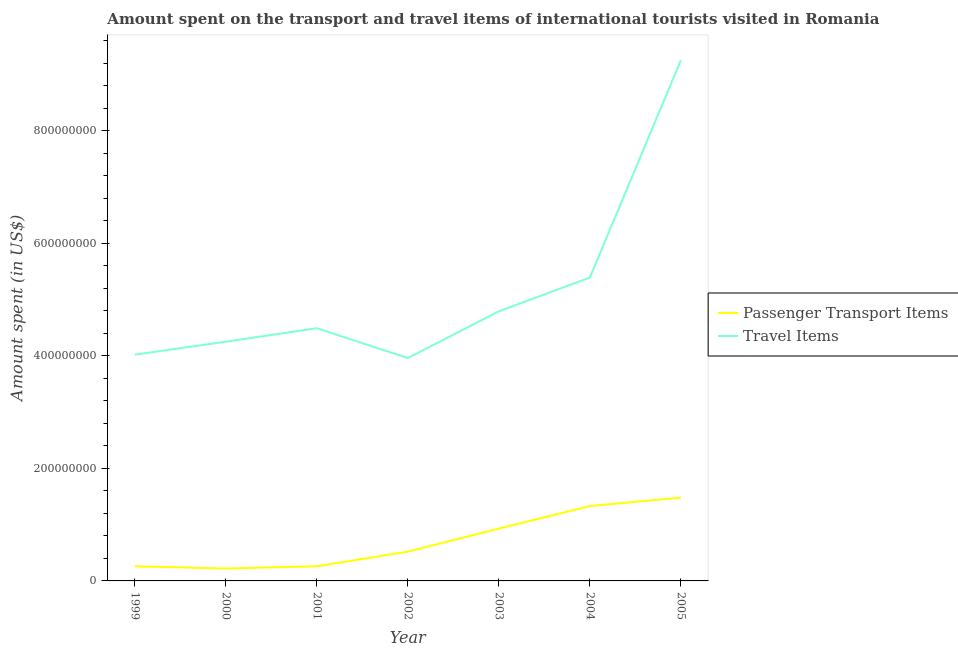What is the amount spent in travel items in 2004?
Give a very brief answer. 5.39e+08. Across all years, what is the maximum amount spent in travel items?
Keep it short and to the point. 9.25e+08. Across all years, what is the minimum amount spent on passenger transport items?
Your answer should be compact. 2.20e+07. In which year was the amount spent on passenger transport items maximum?
Give a very brief answer. 2005. In which year was the amount spent in travel items minimum?
Give a very brief answer. 2002. What is the total amount spent on passenger transport items in the graph?
Your answer should be compact. 5.00e+08. What is the difference between the amount spent on passenger transport items in 2001 and that in 2005?
Provide a short and direct response. -1.22e+08. What is the difference between the amount spent on passenger transport items in 2002 and the amount spent in travel items in 2000?
Ensure brevity in your answer.  -3.73e+08. What is the average amount spent on passenger transport items per year?
Give a very brief answer. 7.14e+07. In the year 2002, what is the difference between the amount spent in travel items and amount spent on passenger transport items?
Provide a short and direct response. 3.44e+08. In how many years, is the amount spent in travel items greater than 920000000 US$?
Ensure brevity in your answer.  1. What is the ratio of the amount spent in travel items in 1999 to that in 2002?
Provide a succinct answer. 1.02. Is the amount spent in travel items in 1999 less than that in 2004?
Make the answer very short. Yes. What is the difference between the highest and the second highest amount spent on passenger transport items?
Offer a very short reply. 1.50e+07. What is the difference between the highest and the lowest amount spent on passenger transport items?
Give a very brief answer. 1.26e+08. In how many years, is the amount spent in travel items greater than the average amount spent in travel items taken over all years?
Provide a succinct answer. 2. Is the sum of the amount spent on passenger transport items in 2003 and 2004 greater than the maximum amount spent in travel items across all years?
Make the answer very short. No. Is the amount spent on passenger transport items strictly greater than the amount spent in travel items over the years?
Your answer should be very brief. No. How many lines are there?
Offer a very short reply. 2. How many years are there in the graph?
Ensure brevity in your answer.  7. Does the graph contain grids?
Offer a very short reply. No. Where does the legend appear in the graph?
Ensure brevity in your answer.  Center right. How are the legend labels stacked?
Offer a terse response. Vertical. What is the title of the graph?
Provide a succinct answer. Amount spent on the transport and travel items of international tourists visited in Romania. What is the label or title of the Y-axis?
Your answer should be compact. Amount spent (in US$). What is the Amount spent (in US$) in Passenger Transport Items in 1999?
Provide a short and direct response. 2.60e+07. What is the Amount spent (in US$) of Travel Items in 1999?
Your response must be concise. 4.02e+08. What is the Amount spent (in US$) of Passenger Transport Items in 2000?
Keep it short and to the point. 2.20e+07. What is the Amount spent (in US$) in Travel Items in 2000?
Give a very brief answer. 4.25e+08. What is the Amount spent (in US$) of Passenger Transport Items in 2001?
Give a very brief answer. 2.60e+07. What is the Amount spent (in US$) of Travel Items in 2001?
Keep it short and to the point. 4.49e+08. What is the Amount spent (in US$) in Passenger Transport Items in 2002?
Your answer should be very brief. 5.20e+07. What is the Amount spent (in US$) of Travel Items in 2002?
Offer a very short reply. 3.96e+08. What is the Amount spent (in US$) in Passenger Transport Items in 2003?
Provide a short and direct response. 9.30e+07. What is the Amount spent (in US$) of Travel Items in 2003?
Provide a short and direct response. 4.79e+08. What is the Amount spent (in US$) of Passenger Transport Items in 2004?
Make the answer very short. 1.33e+08. What is the Amount spent (in US$) in Travel Items in 2004?
Your answer should be compact. 5.39e+08. What is the Amount spent (in US$) of Passenger Transport Items in 2005?
Ensure brevity in your answer.  1.48e+08. What is the Amount spent (in US$) of Travel Items in 2005?
Give a very brief answer. 9.25e+08. Across all years, what is the maximum Amount spent (in US$) in Passenger Transport Items?
Offer a very short reply. 1.48e+08. Across all years, what is the maximum Amount spent (in US$) of Travel Items?
Give a very brief answer. 9.25e+08. Across all years, what is the minimum Amount spent (in US$) in Passenger Transport Items?
Give a very brief answer. 2.20e+07. Across all years, what is the minimum Amount spent (in US$) of Travel Items?
Offer a terse response. 3.96e+08. What is the total Amount spent (in US$) in Passenger Transport Items in the graph?
Ensure brevity in your answer.  5.00e+08. What is the total Amount spent (in US$) in Travel Items in the graph?
Your response must be concise. 3.62e+09. What is the difference between the Amount spent (in US$) in Passenger Transport Items in 1999 and that in 2000?
Offer a very short reply. 4.00e+06. What is the difference between the Amount spent (in US$) of Travel Items in 1999 and that in 2000?
Provide a short and direct response. -2.30e+07. What is the difference between the Amount spent (in US$) in Travel Items in 1999 and that in 2001?
Give a very brief answer. -4.70e+07. What is the difference between the Amount spent (in US$) of Passenger Transport Items in 1999 and that in 2002?
Your answer should be very brief. -2.60e+07. What is the difference between the Amount spent (in US$) in Passenger Transport Items in 1999 and that in 2003?
Give a very brief answer. -6.70e+07. What is the difference between the Amount spent (in US$) of Travel Items in 1999 and that in 2003?
Your answer should be compact. -7.70e+07. What is the difference between the Amount spent (in US$) of Passenger Transport Items in 1999 and that in 2004?
Provide a succinct answer. -1.07e+08. What is the difference between the Amount spent (in US$) of Travel Items in 1999 and that in 2004?
Offer a very short reply. -1.37e+08. What is the difference between the Amount spent (in US$) of Passenger Transport Items in 1999 and that in 2005?
Keep it short and to the point. -1.22e+08. What is the difference between the Amount spent (in US$) in Travel Items in 1999 and that in 2005?
Make the answer very short. -5.23e+08. What is the difference between the Amount spent (in US$) in Travel Items in 2000 and that in 2001?
Your answer should be compact. -2.40e+07. What is the difference between the Amount spent (in US$) in Passenger Transport Items in 2000 and that in 2002?
Your answer should be very brief. -3.00e+07. What is the difference between the Amount spent (in US$) in Travel Items in 2000 and that in 2002?
Your answer should be very brief. 2.90e+07. What is the difference between the Amount spent (in US$) in Passenger Transport Items in 2000 and that in 2003?
Make the answer very short. -7.10e+07. What is the difference between the Amount spent (in US$) of Travel Items in 2000 and that in 2003?
Give a very brief answer. -5.40e+07. What is the difference between the Amount spent (in US$) in Passenger Transport Items in 2000 and that in 2004?
Keep it short and to the point. -1.11e+08. What is the difference between the Amount spent (in US$) of Travel Items in 2000 and that in 2004?
Your answer should be compact. -1.14e+08. What is the difference between the Amount spent (in US$) of Passenger Transport Items in 2000 and that in 2005?
Provide a succinct answer. -1.26e+08. What is the difference between the Amount spent (in US$) of Travel Items in 2000 and that in 2005?
Offer a very short reply. -5.00e+08. What is the difference between the Amount spent (in US$) of Passenger Transport Items in 2001 and that in 2002?
Offer a very short reply. -2.60e+07. What is the difference between the Amount spent (in US$) in Travel Items in 2001 and that in 2002?
Your answer should be very brief. 5.30e+07. What is the difference between the Amount spent (in US$) of Passenger Transport Items in 2001 and that in 2003?
Make the answer very short. -6.70e+07. What is the difference between the Amount spent (in US$) of Travel Items in 2001 and that in 2003?
Your answer should be very brief. -3.00e+07. What is the difference between the Amount spent (in US$) of Passenger Transport Items in 2001 and that in 2004?
Your response must be concise. -1.07e+08. What is the difference between the Amount spent (in US$) in Travel Items in 2001 and that in 2004?
Make the answer very short. -9.00e+07. What is the difference between the Amount spent (in US$) of Passenger Transport Items in 2001 and that in 2005?
Your answer should be very brief. -1.22e+08. What is the difference between the Amount spent (in US$) in Travel Items in 2001 and that in 2005?
Provide a short and direct response. -4.76e+08. What is the difference between the Amount spent (in US$) in Passenger Transport Items in 2002 and that in 2003?
Ensure brevity in your answer.  -4.10e+07. What is the difference between the Amount spent (in US$) of Travel Items in 2002 and that in 2003?
Your answer should be compact. -8.30e+07. What is the difference between the Amount spent (in US$) in Passenger Transport Items in 2002 and that in 2004?
Your answer should be compact. -8.10e+07. What is the difference between the Amount spent (in US$) of Travel Items in 2002 and that in 2004?
Make the answer very short. -1.43e+08. What is the difference between the Amount spent (in US$) of Passenger Transport Items in 2002 and that in 2005?
Provide a short and direct response. -9.60e+07. What is the difference between the Amount spent (in US$) of Travel Items in 2002 and that in 2005?
Give a very brief answer. -5.29e+08. What is the difference between the Amount spent (in US$) of Passenger Transport Items in 2003 and that in 2004?
Your response must be concise. -4.00e+07. What is the difference between the Amount spent (in US$) in Travel Items in 2003 and that in 2004?
Offer a terse response. -6.00e+07. What is the difference between the Amount spent (in US$) in Passenger Transport Items in 2003 and that in 2005?
Give a very brief answer. -5.50e+07. What is the difference between the Amount spent (in US$) in Travel Items in 2003 and that in 2005?
Ensure brevity in your answer.  -4.46e+08. What is the difference between the Amount spent (in US$) in Passenger Transport Items in 2004 and that in 2005?
Offer a very short reply. -1.50e+07. What is the difference between the Amount spent (in US$) of Travel Items in 2004 and that in 2005?
Ensure brevity in your answer.  -3.86e+08. What is the difference between the Amount spent (in US$) in Passenger Transport Items in 1999 and the Amount spent (in US$) in Travel Items in 2000?
Your answer should be very brief. -3.99e+08. What is the difference between the Amount spent (in US$) in Passenger Transport Items in 1999 and the Amount spent (in US$) in Travel Items in 2001?
Make the answer very short. -4.23e+08. What is the difference between the Amount spent (in US$) of Passenger Transport Items in 1999 and the Amount spent (in US$) of Travel Items in 2002?
Give a very brief answer. -3.70e+08. What is the difference between the Amount spent (in US$) of Passenger Transport Items in 1999 and the Amount spent (in US$) of Travel Items in 2003?
Ensure brevity in your answer.  -4.53e+08. What is the difference between the Amount spent (in US$) of Passenger Transport Items in 1999 and the Amount spent (in US$) of Travel Items in 2004?
Keep it short and to the point. -5.13e+08. What is the difference between the Amount spent (in US$) of Passenger Transport Items in 1999 and the Amount spent (in US$) of Travel Items in 2005?
Provide a succinct answer. -8.99e+08. What is the difference between the Amount spent (in US$) in Passenger Transport Items in 2000 and the Amount spent (in US$) in Travel Items in 2001?
Provide a short and direct response. -4.27e+08. What is the difference between the Amount spent (in US$) in Passenger Transport Items in 2000 and the Amount spent (in US$) in Travel Items in 2002?
Make the answer very short. -3.74e+08. What is the difference between the Amount spent (in US$) in Passenger Transport Items in 2000 and the Amount spent (in US$) in Travel Items in 2003?
Give a very brief answer. -4.57e+08. What is the difference between the Amount spent (in US$) in Passenger Transport Items in 2000 and the Amount spent (in US$) in Travel Items in 2004?
Keep it short and to the point. -5.17e+08. What is the difference between the Amount spent (in US$) in Passenger Transport Items in 2000 and the Amount spent (in US$) in Travel Items in 2005?
Offer a terse response. -9.03e+08. What is the difference between the Amount spent (in US$) in Passenger Transport Items in 2001 and the Amount spent (in US$) in Travel Items in 2002?
Your answer should be very brief. -3.70e+08. What is the difference between the Amount spent (in US$) of Passenger Transport Items in 2001 and the Amount spent (in US$) of Travel Items in 2003?
Ensure brevity in your answer.  -4.53e+08. What is the difference between the Amount spent (in US$) of Passenger Transport Items in 2001 and the Amount spent (in US$) of Travel Items in 2004?
Offer a very short reply. -5.13e+08. What is the difference between the Amount spent (in US$) of Passenger Transport Items in 2001 and the Amount spent (in US$) of Travel Items in 2005?
Your response must be concise. -8.99e+08. What is the difference between the Amount spent (in US$) in Passenger Transport Items in 2002 and the Amount spent (in US$) in Travel Items in 2003?
Keep it short and to the point. -4.27e+08. What is the difference between the Amount spent (in US$) of Passenger Transport Items in 2002 and the Amount spent (in US$) of Travel Items in 2004?
Offer a terse response. -4.87e+08. What is the difference between the Amount spent (in US$) of Passenger Transport Items in 2002 and the Amount spent (in US$) of Travel Items in 2005?
Offer a terse response. -8.73e+08. What is the difference between the Amount spent (in US$) of Passenger Transport Items in 2003 and the Amount spent (in US$) of Travel Items in 2004?
Provide a short and direct response. -4.46e+08. What is the difference between the Amount spent (in US$) in Passenger Transport Items in 2003 and the Amount spent (in US$) in Travel Items in 2005?
Offer a terse response. -8.32e+08. What is the difference between the Amount spent (in US$) in Passenger Transport Items in 2004 and the Amount spent (in US$) in Travel Items in 2005?
Offer a terse response. -7.92e+08. What is the average Amount spent (in US$) of Passenger Transport Items per year?
Provide a succinct answer. 7.14e+07. What is the average Amount spent (in US$) of Travel Items per year?
Give a very brief answer. 5.16e+08. In the year 1999, what is the difference between the Amount spent (in US$) of Passenger Transport Items and Amount spent (in US$) of Travel Items?
Your answer should be very brief. -3.76e+08. In the year 2000, what is the difference between the Amount spent (in US$) of Passenger Transport Items and Amount spent (in US$) of Travel Items?
Your answer should be very brief. -4.03e+08. In the year 2001, what is the difference between the Amount spent (in US$) of Passenger Transport Items and Amount spent (in US$) of Travel Items?
Make the answer very short. -4.23e+08. In the year 2002, what is the difference between the Amount spent (in US$) in Passenger Transport Items and Amount spent (in US$) in Travel Items?
Your response must be concise. -3.44e+08. In the year 2003, what is the difference between the Amount spent (in US$) of Passenger Transport Items and Amount spent (in US$) of Travel Items?
Offer a terse response. -3.86e+08. In the year 2004, what is the difference between the Amount spent (in US$) in Passenger Transport Items and Amount spent (in US$) in Travel Items?
Provide a short and direct response. -4.06e+08. In the year 2005, what is the difference between the Amount spent (in US$) of Passenger Transport Items and Amount spent (in US$) of Travel Items?
Provide a short and direct response. -7.77e+08. What is the ratio of the Amount spent (in US$) in Passenger Transport Items in 1999 to that in 2000?
Keep it short and to the point. 1.18. What is the ratio of the Amount spent (in US$) in Travel Items in 1999 to that in 2000?
Offer a very short reply. 0.95. What is the ratio of the Amount spent (in US$) in Passenger Transport Items in 1999 to that in 2001?
Give a very brief answer. 1. What is the ratio of the Amount spent (in US$) in Travel Items in 1999 to that in 2001?
Make the answer very short. 0.9. What is the ratio of the Amount spent (in US$) of Travel Items in 1999 to that in 2002?
Make the answer very short. 1.02. What is the ratio of the Amount spent (in US$) of Passenger Transport Items in 1999 to that in 2003?
Offer a very short reply. 0.28. What is the ratio of the Amount spent (in US$) in Travel Items in 1999 to that in 2003?
Provide a short and direct response. 0.84. What is the ratio of the Amount spent (in US$) of Passenger Transport Items in 1999 to that in 2004?
Offer a very short reply. 0.2. What is the ratio of the Amount spent (in US$) of Travel Items in 1999 to that in 2004?
Ensure brevity in your answer.  0.75. What is the ratio of the Amount spent (in US$) in Passenger Transport Items in 1999 to that in 2005?
Make the answer very short. 0.18. What is the ratio of the Amount spent (in US$) of Travel Items in 1999 to that in 2005?
Give a very brief answer. 0.43. What is the ratio of the Amount spent (in US$) of Passenger Transport Items in 2000 to that in 2001?
Give a very brief answer. 0.85. What is the ratio of the Amount spent (in US$) of Travel Items in 2000 to that in 2001?
Give a very brief answer. 0.95. What is the ratio of the Amount spent (in US$) of Passenger Transport Items in 2000 to that in 2002?
Provide a succinct answer. 0.42. What is the ratio of the Amount spent (in US$) of Travel Items in 2000 to that in 2002?
Provide a succinct answer. 1.07. What is the ratio of the Amount spent (in US$) in Passenger Transport Items in 2000 to that in 2003?
Keep it short and to the point. 0.24. What is the ratio of the Amount spent (in US$) of Travel Items in 2000 to that in 2003?
Offer a very short reply. 0.89. What is the ratio of the Amount spent (in US$) of Passenger Transport Items in 2000 to that in 2004?
Ensure brevity in your answer.  0.17. What is the ratio of the Amount spent (in US$) in Travel Items in 2000 to that in 2004?
Offer a very short reply. 0.79. What is the ratio of the Amount spent (in US$) in Passenger Transport Items in 2000 to that in 2005?
Your answer should be compact. 0.15. What is the ratio of the Amount spent (in US$) in Travel Items in 2000 to that in 2005?
Ensure brevity in your answer.  0.46. What is the ratio of the Amount spent (in US$) in Passenger Transport Items in 2001 to that in 2002?
Ensure brevity in your answer.  0.5. What is the ratio of the Amount spent (in US$) in Travel Items in 2001 to that in 2002?
Ensure brevity in your answer.  1.13. What is the ratio of the Amount spent (in US$) of Passenger Transport Items in 2001 to that in 2003?
Your response must be concise. 0.28. What is the ratio of the Amount spent (in US$) of Travel Items in 2001 to that in 2003?
Provide a succinct answer. 0.94. What is the ratio of the Amount spent (in US$) in Passenger Transport Items in 2001 to that in 2004?
Give a very brief answer. 0.2. What is the ratio of the Amount spent (in US$) of Travel Items in 2001 to that in 2004?
Your response must be concise. 0.83. What is the ratio of the Amount spent (in US$) of Passenger Transport Items in 2001 to that in 2005?
Provide a succinct answer. 0.18. What is the ratio of the Amount spent (in US$) of Travel Items in 2001 to that in 2005?
Your answer should be compact. 0.49. What is the ratio of the Amount spent (in US$) in Passenger Transport Items in 2002 to that in 2003?
Offer a terse response. 0.56. What is the ratio of the Amount spent (in US$) of Travel Items in 2002 to that in 2003?
Offer a very short reply. 0.83. What is the ratio of the Amount spent (in US$) in Passenger Transport Items in 2002 to that in 2004?
Your response must be concise. 0.39. What is the ratio of the Amount spent (in US$) of Travel Items in 2002 to that in 2004?
Your answer should be very brief. 0.73. What is the ratio of the Amount spent (in US$) of Passenger Transport Items in 2002 to that in 2005?
Ensure brevity in your answer.  0.35. What is the ratio of the Amount spent (in US$) of Travel Items in 2002 to that in 2005?
Offer a terse response. 0.43. What is the ratio of the Amount spent (in US$) of Passenger Transport Items in 2003 to that in 2004?
Offer a terse response. 0.7. What is the ratio of the Amount spent (in US$) in Travel Items in 2003 to that in 2004?
Keep it short and to the point. 0.89. What is the ratio of the Amount spent (in US$) of Passenger Transport Items in 2003 to that in 2005?
Make the answer very short. 0.63. What is the ratio of the Amount spent (in US$) of Travel Items in 2003 to that in 2005?
Your answer should be very brief. 0.52. What is the ratio of the Amount spent (in US$) in Passenger Transport Items in 2004 to that in 2005?
Provide a short and direct response. 0.9. What is the ratio of the Amount spent (in US$) in Travel Items in 2004 to that in 2005?
Your answer should be very brief. 0.58. What is the difference between the highest and the second highest Amount spent (in US$) of Passenger Transport Items?
Provide a succinct answer. 1.50e+07. What is the difference between the highest and the second highest Amount spent (in US$) of Travel Items?
Your answer should be compact. 3.86e+08. What is the difference between the highest and the lowest Amount spent (in US$) in Passenger Transport Items?
Your answer should be compact. 1.26e+08. What is the difference between the highest and the lowest Amount spent (in US$) of Travel Items?
Provide a short and direct response. 5.29e+08. 